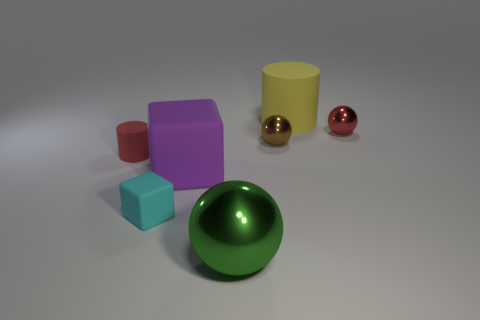How many things are big gray cylinders or small objects in front of the big cube?
Offer a very short reply. 1. There is a rubber cylinder in front of the small red metal thing; is its size the same as the matte block on the right side of the cyan object?
Your response must be concise. No. How many tiny shiny objects have the same shape as the large green thing?
Ensure brevity in your answer.  2. What is the shape of the big purple object that is made of the same material as the tiny cyan object?
Offer a terse response. Cube. There is a red object that is on the right side of the red thing left of the shiny object that is in front of the small red rubber thing; what is its material?
Offer a very short reply. Metal. Is the size of the yellow rubber cylinder the same as the cylinder in front of the big yellow rubber object?
Provide a succinct answer. No. What is the material of the green thing that is the same shape as the brown object?
Offer a terse response. Metal. There is a cylinder that is to the right of the tiny rubber cylinder in front of the matte cylinder that is to the right of the green metal ball; what size is it?
Your response must be concise. Large. Do the purple rubber cube and the red metal thing have the same size?
Provide a short and direct response. No. There is a big object that is to the left of the metallic thing that is in front of the big purple rubber cube; what is it made of?
Provide a succinct answer. Rubber. 